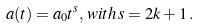<formula> <loc_0><loc_0><loc_500><loc_500>a ( t ) = a _ { 0 } t ^ { s } , \, w i t h \, s = 2 k + 1 \, .</formula> 